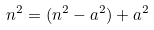Convert formula to latex. <formula><loc_0><loc_0><loc_500><loc_500>n ^ { 2 } = ( n ^ { 2 } - a ^ { 2 } ) + a ^ { 2 }</formula> 